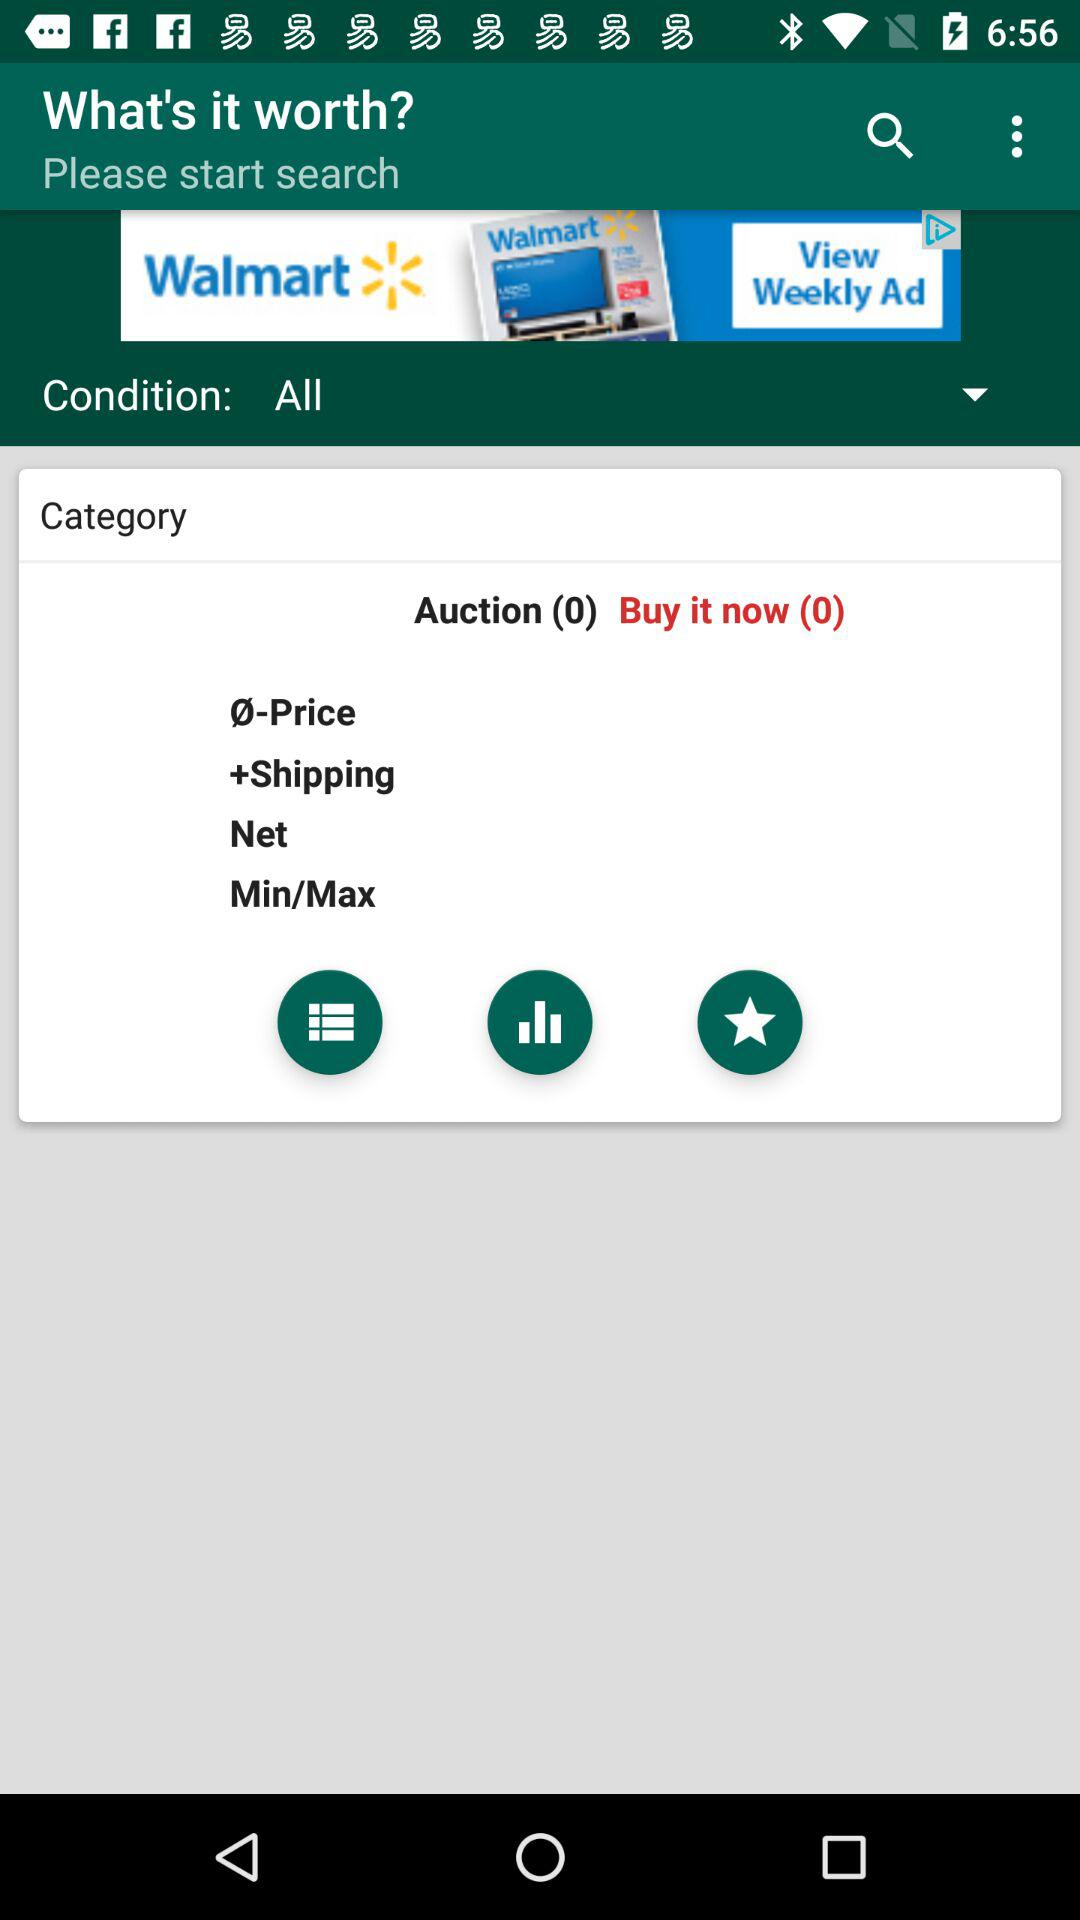What is the number of the auction? The number of the auction is 0. 